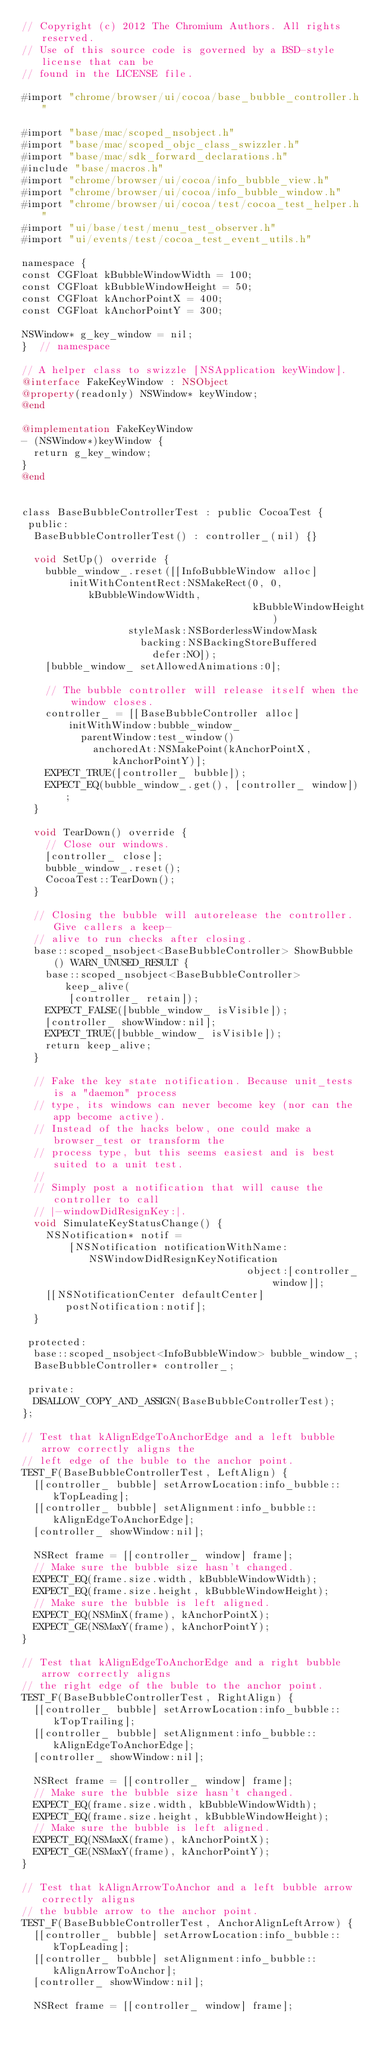Convert code to text. <code><loc_0><loc_0><loc_500><loc_500><_ObjectiveC_>// Copyright (c) 2012 The Chromium Authors. All rights reserved.
// Use of this source code is governed by a BSD-style license that can be
// found in the LICENSE file.

#import "chrome/browser/ui/cocoa/base_bubble_controller.h"

#import "base/mac/scoped_nsobject.h"
#import "base/mac/scoped_objc_class_swizzler.h"
#import "base/mac/sdk_forward_declarations.h"
#include "base/macros.h"
#import "chrome/browser/ui/cocoa/info_bubble_view.h"
#import "chrome/browser/ui/cocoa/info_bubble_window.h"
#import "chrome/browser/ui/cocoa/test/cocoa_test_helper.h"
#import "ui/base/test/menu_test_observer.h"
#import "ui/events/test/cocoa_test_event_utils.h"

namespace {
const CGFloat kBubbleWindowWidth = 100;
const CGFloat kBubbleWindowHeight = 50;
const CGFloat kAnchorPointX = 400;
const CGFloat kAnchorPointY = 300;

NSWindow* g_key_window = nil;
}  // namespace

// A helper class to swizzle [NSApplication keyWindow].
@interface FakeKeyWindow : NSObject
@property(readonly) NSWindow* keyWindow;
@end

@implementation FakeKeyWindow
- (NSWindow*)keyWindow {
  return g_key_window;
}
@end


class BaseBubbleControllerTest : public CocoaTest {
 public:
  BaseBubbleControllerTest() : controller_(nil) {}

  void SetUp() override {
    bubble_window_.reset([[InfoBubbleWindow alloc]
        initWithContentRect:NSMakeRect(0, 0, kBubbleWindowWidth,
                                       kBubbleWindowHeight)
                  styleMask:NSBorderlessWindowMask
                    backing:NSBackingStoreBuffered
                      defer:NO]);
    [bubble_window_ setAllowedAnimations:0];

    // The bubble controller will release itself when the window closes.
    controller_ = [[BaseBubbleController alloc]
        initWithWindow:bubble_window_
          parentWindow:test_window()
            anchoredAt:NSMakePoint(kAnchorPointX, kAnchorPointY)];
    EXPECT_TRUE([controller_ bubble]);
    EXPECT_EQ(bubble_window_.get(), [controller_ window]);
  }

  void TearDown() override {
    // Close our windows.
    [controller_ close];
    bubble_window_.reset();
    CocoaTest::TearDown();
  }

  // Closing the bubble will autorelease the controller. Give callers a keep-
  // alive to run checks after closing.
  base::scoped_nsobject<BaseBubbleController> ShowBubble() WARN_UNUSED_RESULT {
    base::scoped_nsobject<BaseBubbleController> keep_alive(
        [controller_ retain]);
    EXPECT_FALSE([bubble_window_ isVisible]);
    [controller_ showWindow:nil];
    EXPECT_TRUE([bubble_window_ isVisible]);
    return keep_alive;
  }

  // Fake the key state notification. Because unit_tests is a "daemon" process
  // type, its windows can never become key (nor can the app become active).
  // Instead of the hacks below, one could make a browser_test or transform the
  // process type, but this seems easiest and is best suited to a unit test.
  //
  // Simply post a notification that will cause the controller to call
  // |-windowDidResignKey:|.
  void SimulateKeyStatusChange() {
    NSNotification* notif =
        [NSNotification notificationWithName:NSWindowDidResignKeyNotification
                                      object:[controller_ window]];
    [[NSNotificationCenter defaultCenter] postNotification:notif];
  }

 protected:
  base::scoped_nsobject<InfoBubbleWindow> bubble_window_;
  BaseBubbleController* controller_;

 private:
  DISALLOW_COPY_AND_ASSIGN(BaseBubbleControllerTest);
};

// Test that kAlignEdgeToAnchorEdge and a left bubble arrow correctly aligns the
// left edge of the buble to the anchor point.
TEST_F(BaseBubbleControllerTest, LeftAlign) {
  [[controller_ bubble] setArrowLocation:info_bubble::kTopLeading];
  [[controller_ bubble] setAlignment:info_bubble::kAlignEdgeToAnchorEdge];
  [controller_ showWindow:nil];

  NSRect frame = [[controller_ window] frame];
  // Make sure the bubble size hasn't changed.
  EXPECT_EQ(frame.size.width, kBubbleWindowWidth);
  EXPECT_EQ(frame.size.height, kBubbleWindowHeight);
  // Make sure the bubble is left aligned.
  EXPECT_EQ(NSMinX(frame), kAnchorPointX);
  EXPECT_GE(NSMaxY(frame), kAnchorPointY);
}

// Test that kAlignEdgeToAnchorEdge and a right bubble arrow correctly aligns
// the right edge of the buble to the anchor point.
TEST_F(BaseBubbleControllerTest, RightAlign) {
  [[controller_ bubble] setArrowLocation:info_bubble::kTopTrailing];
  [[controller_ bubble] setAlignment:info_bubble::kAlignEdgeToAnchorEdge];
  [controller_ showWindow:nil];

  NSRect frame = [[controller_ window] frame];
  // Make sure the bubble size hasn't changed.
  EXPECT_EQ(frame.size.width, kBubbleWindowWidth);
  EXPECT_EQ(frame.size.height, kBubbleWindowHeight);
  // Make sure the bubble is left aligned.
  EXPECT_EQ(NSMaxX(frame), kAnchorPointX);
  EXPECT_GE(NSMaxY(frame), kAnchorPointY);
}

// Test that kAlignArrowToAnchor and a left bubble arrow correctly aligns
// the bubble arrow to the anchor point.
TEST_F(BaseBubbleControllerTest, AnchorAlignLeftArrow) {
  [[controller_ bubble] setArrowLocation:info_bubble::kTopLeading];
  [[controller_ bubble] setAlignment:info_bubble::kAlignArrowToAnchor];
  [controller_ showWindow:nil];

  NSRect frame = [[controller_ window] frame];</code> 